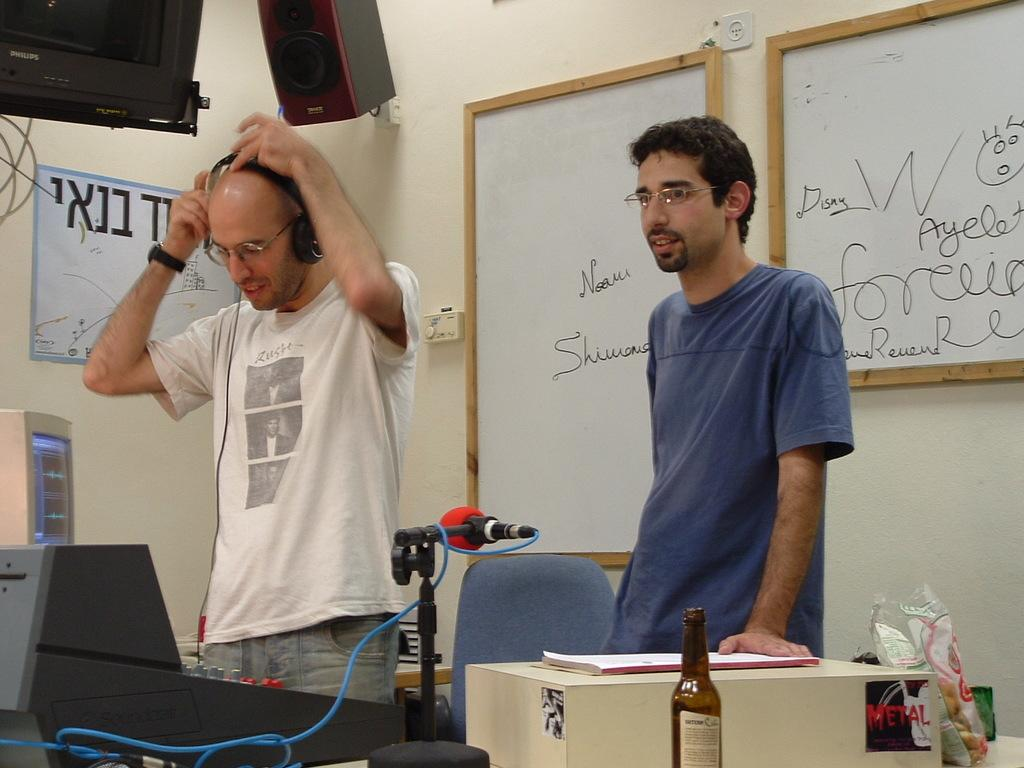<image>
Offer a succinct explanation of the picture presented. Two men wearing glasses stand in a room with a computer, microphone, and sound board. 